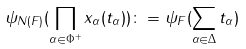Convert formula to latex. <formula><loc_0><loc_0><loc_500><loc_500>\psi _ { N ( F ) } ( \prod _ { \alpha \in \Phi ^ { + } } x _ { \alpha } ( t _ { \alpha } ) ) \colon = \psi _ { F } ( \sum _ { \alpha \in \Delta } t _ { \alpha } )</formula> 